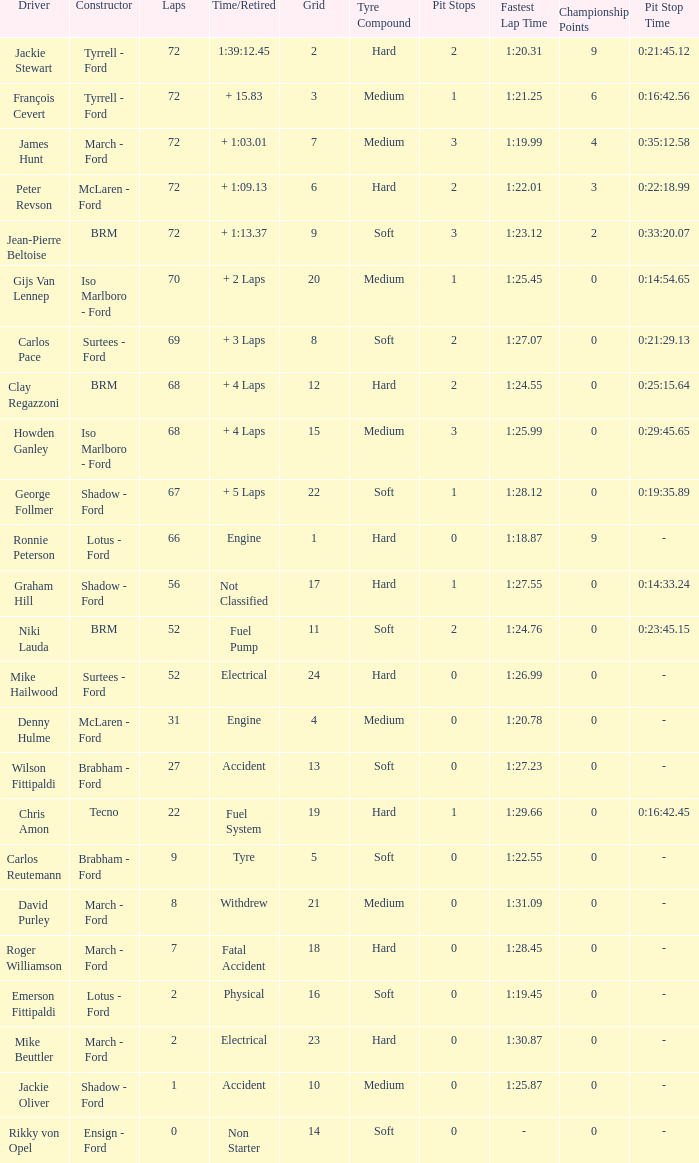Would you be able to parse every entry in this table? {'header': ['Driver', 'Constructor', 'Laps', 'Time/Retired', 'Grid', 'Tyre Compound', 'Pit Stops', 'Fastest Lap Time', 'Championship Points', 'Pit Stop Time'], 'rows': [['Jackie Stewart', 'Tyrrell - Ford', '72', '1:39:12.45', '2', 'Hard', '2', '1:20.31', '9', '0:21:45.12'], ['François Cevert', 'Tyrrell - Ford', '72', '+ 15.83', '3', 'Medium', '1', '1:21.25', '6', '0:16:42.56'], ['James Hunt', 'March - Ford', '72', '+ 1:03.01', '7', 'Medium', '3', '1:19.99', '4', '0:35:12.58'], ['Peter Revson', 'McLaren - Ford', '72', '+ 1:09.13', '6', 'Hard', '2', '1:22.01', '3', '0:22:18.99'], ['Jean-Pierre Beltoise', 'BRM', '72', '+ 1:13.37', '9', 'Soft', '3', '1:23.12', '2', '0:33:20.07'], ['Gijs Van Lennep', 'Iso Marlboro - Ford', '70', '+ 2 Laps', '20', 'Medium', '1', '1:25.45', '0', '0:14:54.65'], ['Carlos Pace', 'Surtees - Ford', '69', '+ 3 Laps', '8', 'Soft', '2', '1:27.07', '0', '0:21:29.13'], ['Clay Regazzoni', 'BRM', '68', '+ 4 Laps', '12', 'Hard', '2', '1:24.55', '0', '0:25:15.64'], ['Howden Ganley', 'Iso Marlboro - Ford', '68', '+ 4 Laps', '15', 'Medium', '3', '1:25.99', '0', '0:29:45.65'], ['George Follmer', 'Shadow - Ford', '67', '+ 5 Laps', '22', 'Soft', '1', '1:28.12', '0', '0:19:35.89'], ['Ronnie Peterson', 'Lotus - Ford', '66', 'Engine', '1', 'Hard', '0', '1:18.87', '9', '-'], ['Graham Hill', 'Shadow - Ford', '56', 'Not Classified', '17', 'Hard', '1', '1:27.55', '0', '0:14:33.24'], ['Niki Lauda', 'BRM', '52', 'Fuel Pump', '11', 'Soft', '2', '1:24.76', '0', '0:23:45.15'], ['Mike Hailwood', 'Surtees - Ford', '52', 'Electrical', '24', 'Hard', '0', '1:26.99', '0', '-'], ['Denny Hulme', 'McLaren - Ford', '31', 'Engine', '4', 'Medium', '0', '1:20.78', '0', '-'], ['Wilson Fittipaldi', 'Brabham - Ford', '27', 'Accident', '13', 'Soft', '0', '1:27.23', '0', '-'], ['Chris Amon', 'Tecno', '22', 'Fuel System', '19', 'Hard', '1', '1:29.66', '0', '0:16:42.45'], ['Carlos Reutemann', 'Brabham - Ford', '9', 'Tyre', '5', 'Soft', '0', '1:22.55', '0', '-'], ['David Purley', 'March - Ford', '8', 'Withdrew', '21', 'Medium', '0', '1:31.09', '0', '-'], ['Roger Williamson', 'March - Ford', '7', 'Fatal Accident', '18', 'Hard', '0', '1:28.45', '0', '-'], ['Emerson Fittipaldi', 'Lotus - Ford', '2', 'Physical', '16', 'Soft', '0', '1:19.45', '0', '-'], ['Mike Beuttler', 'March - Ford', '2', 'Electrical', '23', 'Hard', '0', '1:30.87', '0', '-'], ['Jackie Oliver', 'Shadow - Ford', '1', 'Accident', '10', 'Medium', '0', '1:25.87', '0', '-'], ['Rikky von Opel', 'Ensign - Ford', '0', 'Non Starter', '14', 'Soft', '0', '-', '0', '-']]} What is the top grid that roger williamson lapped less than 7? None. 